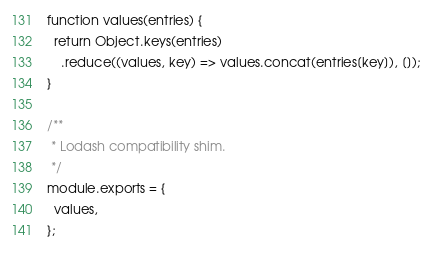Convert code to text. <code><loc_0><loc_0><loc_500><loc_500><_JavaScript_>function values(entries) {
  return Object.keys(entries)
    .reduce((values, key) => values.concat(entries[key]), []);
}

/**
 * Lodash compatibility shim.
 */
module.exports = {
  values,
};
</code> 